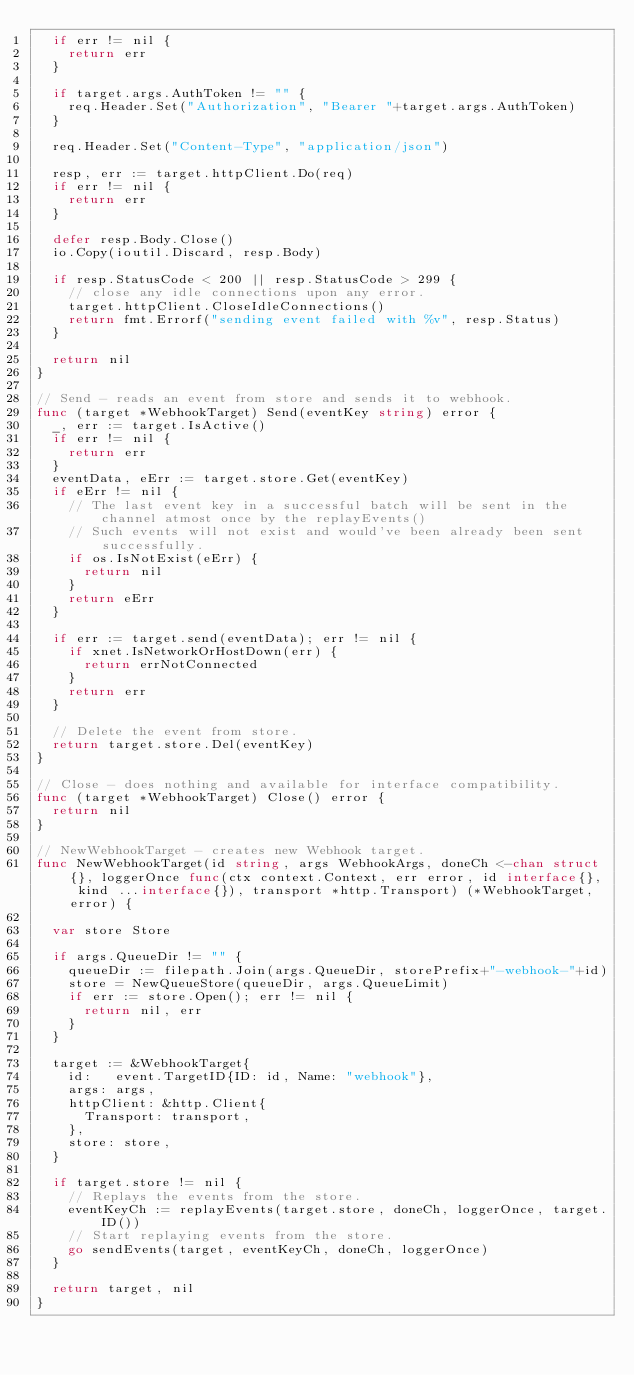<code> <loc_0><loc_0><loc_500><loc_500><_Go_>	if err != nil {
		return err
	}

	if target.args.AuthToken != "" {
		req.Header.Set("Authorization", "Bearer "+target.args.AuthToken)
	}

	req.Header.Set("Content-Type", "application/json")

	resp, err := target.httpClient.Do(req)
	if err != nil {
		return err
	}

	defer resp.Body.Close()
	io.Copy(ioutil.Discard, resp.Body)

	if resp.StatusCode < 200 || resp.StatusCode > 299 {
		// close any idle connections upon any error.
		target.httpClient.CloseIdleConnections()
		return fmt.Errorf("sending event failed with %v", resp.Status)
	}

	return nil
}

// Send - reads an event from store and sends it to webhook.
func (target *WebhookTarget) Send(eventKey string) error {
	_, err := target.IsActive()
	if err != nil {
		return err
	}
	eventData, eErr := target.store.Get(eventKey)
	if eErr != nil {
		// The last event key in a successful batch will be sent in the channel atmost once by the replayEvents()
		// Such events will not exist and would've been already been sent successfully.
		if os.IsNotExist(eErr) {
			return nil
		}
		return eErr
	}

	if err := target.send(eventData); err != nil {
		if xnet.IsNetworkOrHostDown(err) {
			return errNotConnected
		}
		return err
	}

	// Delete the event from store.
	return target.store.Del(eventKey)
}

// Close - does nothing and available for interface compatibility.
func (target *WebhookTarget) Close() error {
	return nil
}

// NewWebhookTarget - creates new Webhook target.
func NewWebhookTarget(id string, args WebhookArgs, doneCh <-chan struct{}, loggerOnce func(ctx context.Context, err error, id interface{}, kind ...interface{}), transport *http.Transport) (*WebhookTarget, error) {

	var store Store

	if args.QueueDir != "" {
		queueDir := filepath.Join(args.QueueDir, storePrefix+"-webhook-"+id)
		store = NewQueueStore(queueDir, args.QueueLimit)
		if err := store.Open(); err != nil {
			return nil, err
		}
	}

	target := &WebhookTarget{
		id:   event.TargetID{ID: id, Name: "webhook"},
		args: args,
		httpClient: &http.Client{
			Transport: transport,
		},
		store: store,
	}

	if target.store != nil {
		// Replays the events from the store.
		eventKeyCh := replayEvents(target.store, doneCh, loggerOnce, target.ID())
		// Start replaying events from the store.
		go sendEvents(target, eventKeyCh, doneCh, loggerOnce)
	}

	return target, nil
}
</code> 